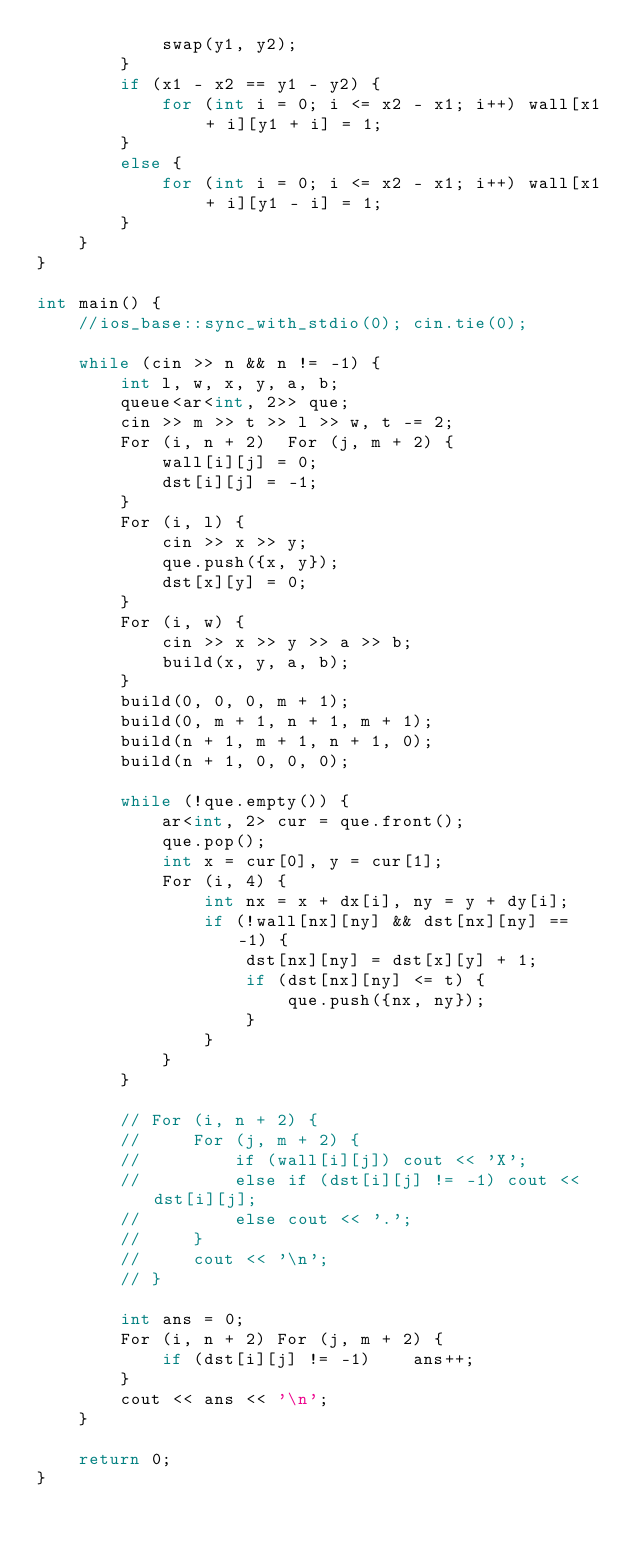<code> <loc_0><loc_0><loc_500><loc_500><_C++_>            swap(y1, y2);
        }
        if (x1 - x2 == y1 - y2) {
            for (int i = 0; i <= x2 - x1; i++) wall[x1 + i][y1 + i] = 1;
        }
        else {
            for (int i = 0; i <= x2 - x1; i++) wall[x1 + i][y1 - i] = 1;
        }
    }
}

int main() {
    //ios_base::sync_with_stdio(0); cin.tie(0);

    while (cin >> n && n != -1) {
        int l, w, x, y, a, b;
        queue<ar<int, 2>> que;
        cin >> m >> t >> l >> w, t -= 2;
        For (i, n + 2)  For (j, m + 2) {
            wall[i][j] = 0;
            dst[i][j] = -1;
        }
        For (i, l) {
            cin >> x >> y;
            que.push({x, y});
            dst[x][y] = 0;
        }
        For (i, w) {
            cin >> x >> y >> a >> b;
            build(x, y, a, b);
        }
        build(0, 0, 0, m + 1);
        build(0, m + 1, n + 1, m + 1);
        build(n + 1, m + 1, n + 1, 0);
        build(n + 1, 0, 0, 0);

        while (!que.empty()) {
            ar<int, 2> cur = que.front();
            que.pop();
            int x = cur[0], y = cur[1];
            For (i, 4) {
                int nx = x + dx[i], ny = y + dy[i];
                if (!wall[nx][ny] && dst[nx][ny] == -1) {
                    dst[nx][ny] = dst[x][y] + 1;
                    if (dst[nx][ny] <= t) {
                        que.push({nx, ny});
                    }
                }
            }
        }

        // For (i, n + 2) {
        //     For (j, m + 2) {
        //         if (wall[i][j]) cout << 'X';
        //         else if (dst[i][j] != -1) cout << dst[i][j];
        //         else cout << '.';
        //     }
        //     cout << '\n';
        // }

        int ans = 0;
        For (i, n + 2) For (j, m + 2) {
            if (dst[i][j] != -1)    ans++;
        }
        cout << ans << '\n';
    }

    return 0;
}</code> 